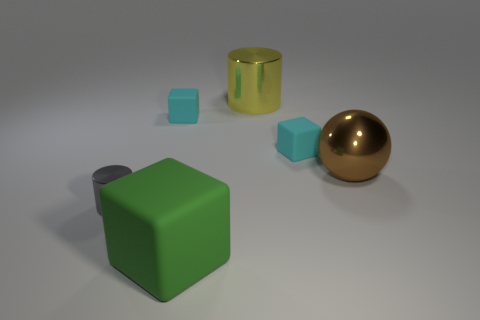Add 3 metallic objects. How many objects exist? 9 Subtract all cylinders. How many objects are left? 4 Add 6 large green objects. How many large green objects are left? 7 Add 4 brown balls. How many brown balls exist? 5 Subtract 0 yellow balls. How many objects are left? 6 Subtract all yellow cylinders. Subtract all tiny purple metal spheres. How many objects are left? 5 